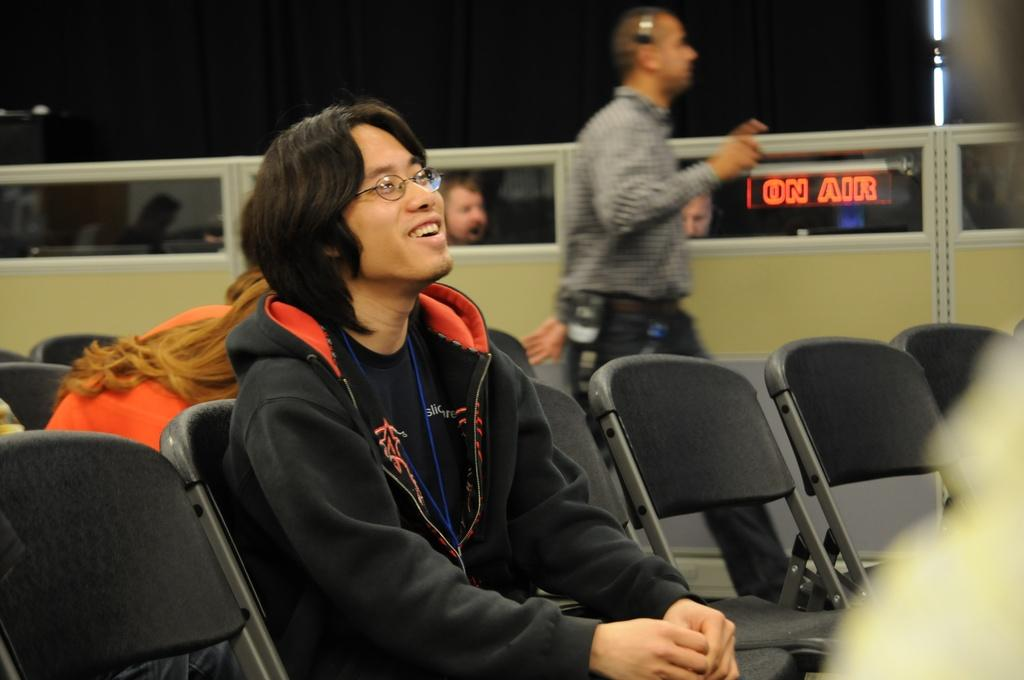What is the person in the foreground of the image doing? The person is sitting on a chair in the image. What is the person wearing? The person is wearing a jacket and glasses. What can be seen in the background of the image? There is a person walking and empty chairs in the background of the image. What type of coal is being used to power the cent in the image? There is no coal or cent present in the image. 